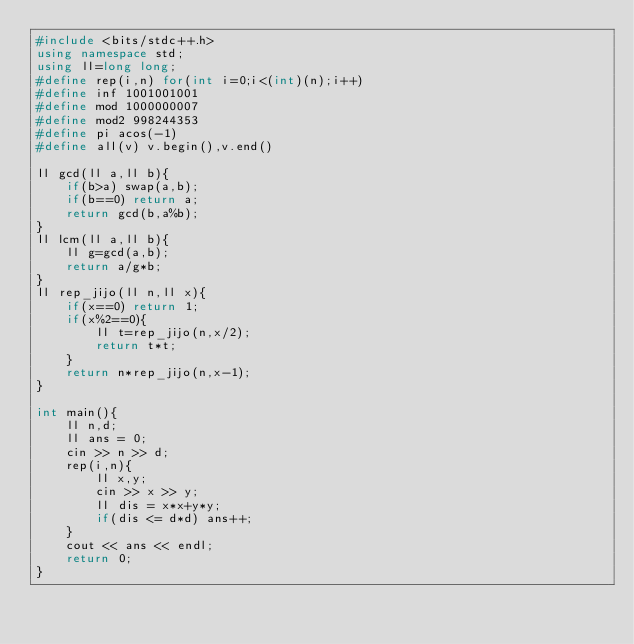<code> <loc_0><loc_0><loc_500><loc_500><_C++_>#include <bits/stdc++.h>
using namespace std;
using ll=long long;
#define rep(i,n) for(int i=0;i<(int)(n);i++)
#define inf 1001001001
#define mod 1000000007
#define mod2 998244353
#define pi acos(-1)
#define all(v) v.begin(),v.end()

ll gcd(ll a,ll b){
    if(b>a) swap(a,b);
    if(b==0) return a;
    return gcd(b,a%b);
}
ll lcm(ll a,ll b){
    ll g=gcd(a,b);
    return a/g*b;
}
ll rep_jijo(ll n,ll x){
    if(x==0) return 1;
    if(x%2==0){
        ll t=rep_jijo(n,x/2);
        return t*t;
    }
    return n*rep_jijo(n,x-1);
}

int main(){
    ll n,d;
    ll ans = 0;
    cin >> n >> d;
    rep(i,n){
        ll x,y;
        cin >> x >> y;
        ll dis = x*x+y*y;
        if(dis <= d*d) ans++;
    }
    cout << ans << endl;
    return 0;
}</code> 